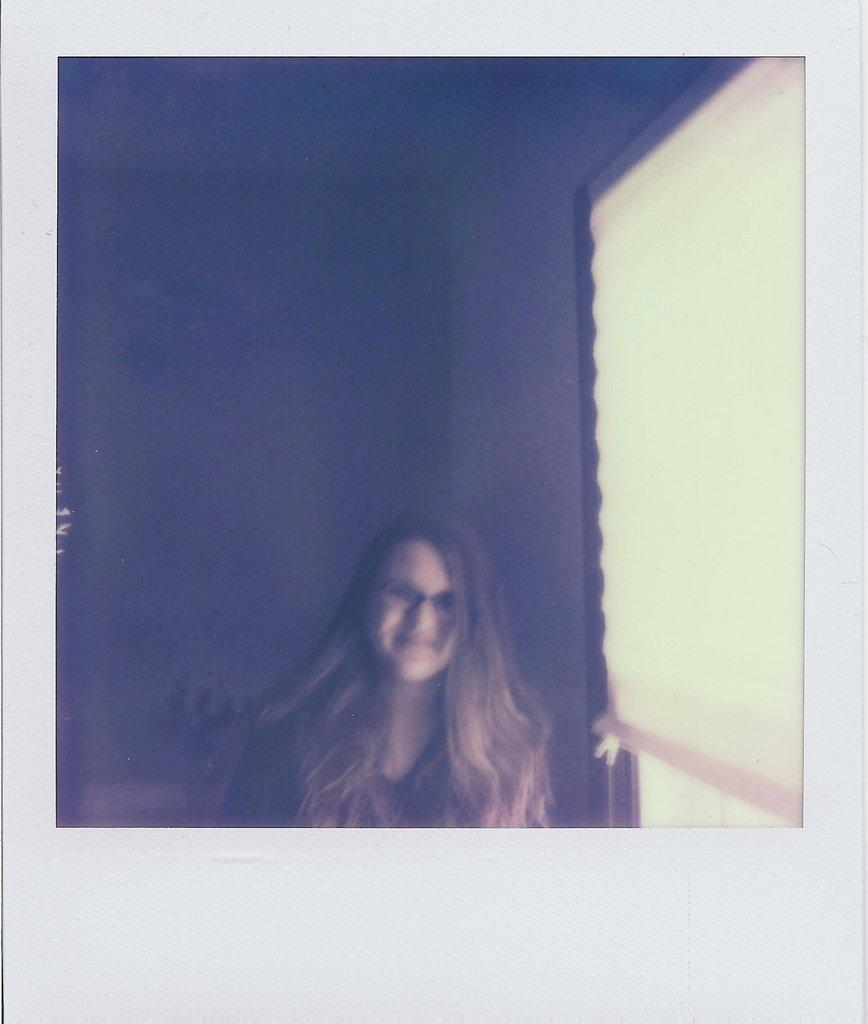What is the main subject of the image? There is a photo in the image. Can you describe the setting of the image? There is a woman in the room. What architectural feature is present in the room? There is a window in the room. What type of silk is draped over the bomb in the image? There is no bomb or silk present in the image. 